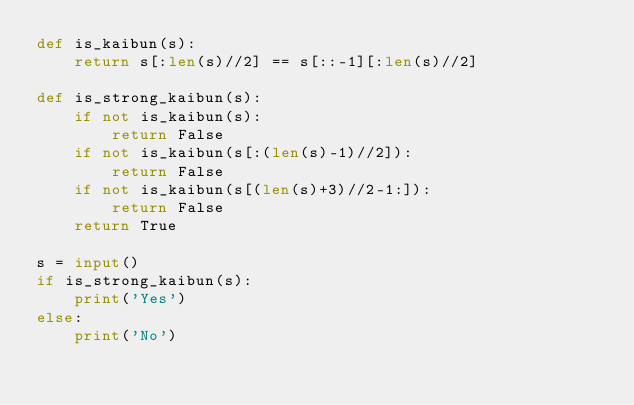Convert code to text. <code><loc_0><loc_0><loc_500><loc_500><_Python_>def is_kaibun(s):
    return s[:len(s)//2] == s[::-1][:len(s)//2]

def is_strong_kaibun(s):
    if not is_kaibun(s):
        return False
    if not is_kaibun(s[:(len(s)-1)//2]):
        return False
    if not is_kaibun(s[(len(s)+3)//2-1:]):
        return False
    return True
  
s = input()
if is_strong_kaibun(s):
    print('Yes')
else:
    print('No')</code> 